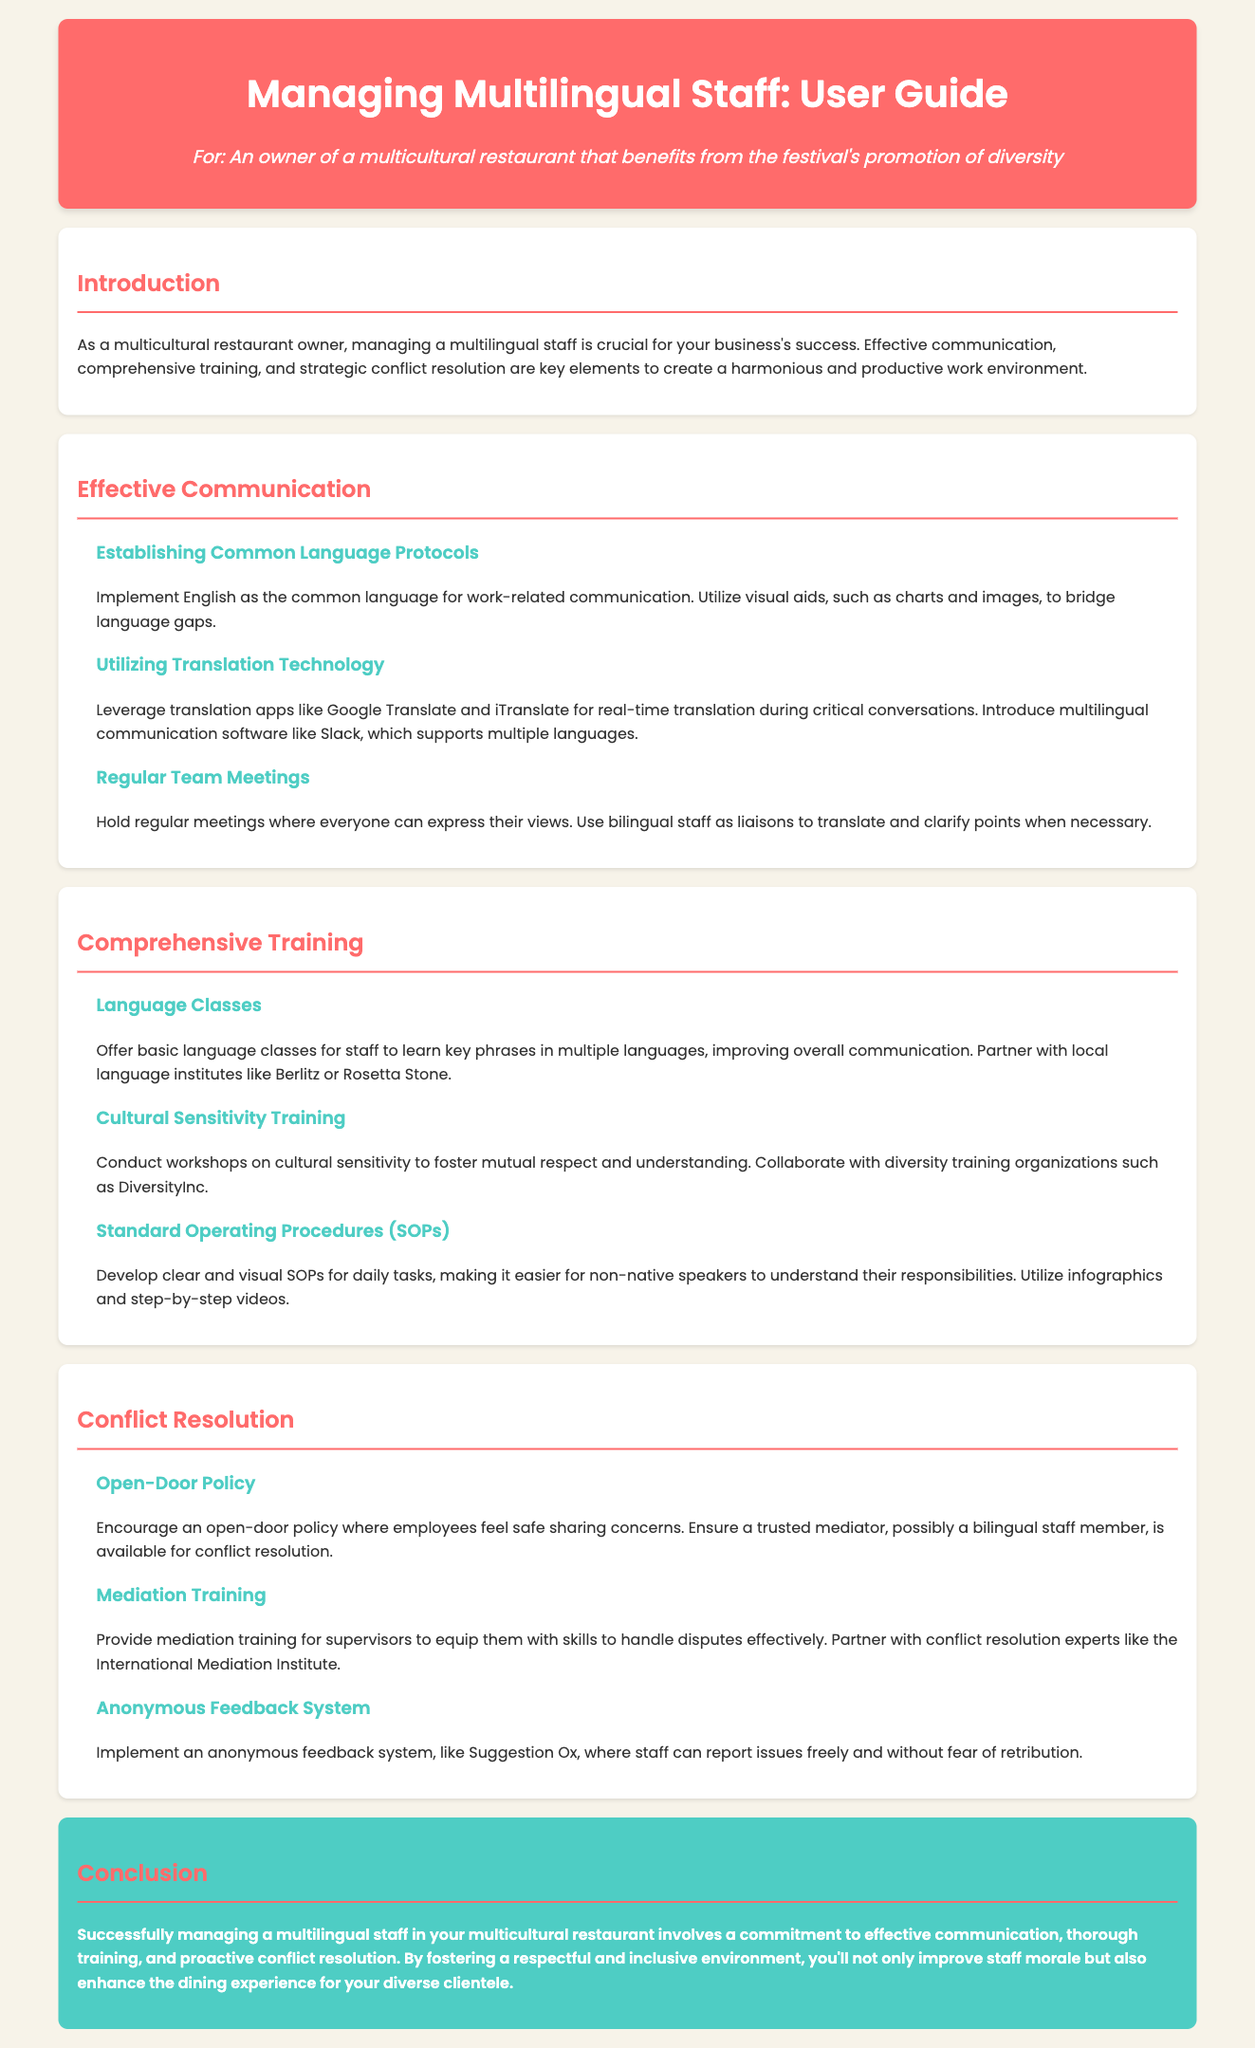what is the main focus of the user guide? The main focus of the user guide is to provide strategies for managing multilingual staff in a multicultural restaurant, emphasizing effective communication, training, and conflict resolution.
Answer: managing multilingual staff who should you partner with for language classes? The document suggests partnering with local language institutes like Berlitz or Rosetta Stone for language classes.
Answer: Berlitz or Rosetta Stone what technology is recommended for real-time translation? Translation apps like Google Translate and iTranslate are recommended for real-time translation.
Answer: Google Translate and iTranslate what training is suggested to foster mutual respect? Cultural sensitivity training is suggested to foster mutual respect and understanding among staff.
Answer: Cultural sensitivity training how can staff report issues anonymously? An anonymous feedback system, like Suggestion Ox, is recommended for staff to report issues freely.
Answer: Suggestion Ox 